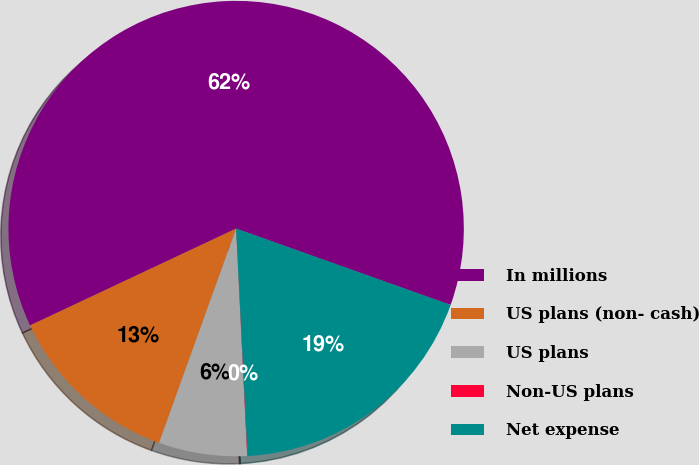<chart> <loc_0><loc_0><loc_500><loc_500><pie_chart><fcel>In millions<fcel>US plans (non- cash)<fcel>US plans<fcel>Non-US plans<fcel>Net expense<nl><fcel>62.43%<fcel>12.51%<fcel>6.27%<fcel>0.03%<fcel>18.75%<nl></chart> 